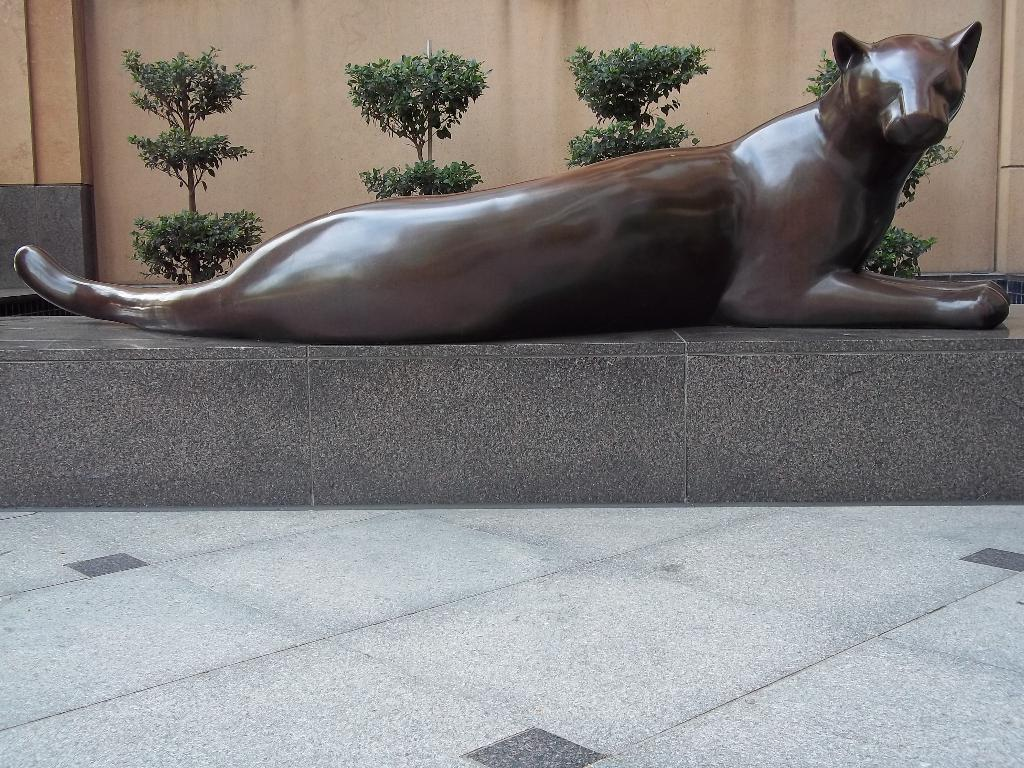What is the main subject of the image? There is a brown color cheetah statue in the image. What is the cheetah statue sitting on? The cheetah statue is sitting on a stone. What type of vegetation can be seen in the background of the image? There are small green plants in the background of the image. What type of flooring is visible in the image? The flooring tiles are visible in the front bottom side of the image. Can you tell me how many vases are placed on the floor in the image? There are no vases present in the image; it features a cheetah statue sitting on a stone. What type of order is being followed by the cheetah statue in the image? The cheetah statue is a stationary object and does not follow any order in the image. 